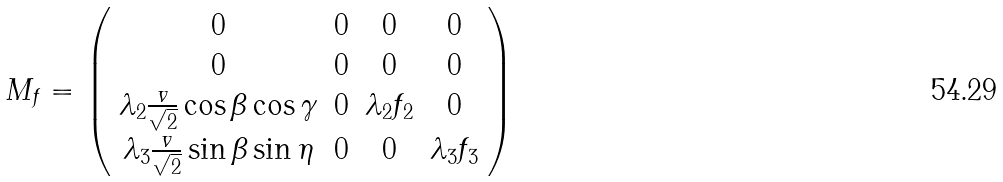<formula> <loc_0><loc_0><loc_500><loc_500>M _ { f } = \left ( \begin{array} { c c c c } 0 & 0 & 0 & 0 \\ 0 & 0 & 0 & 0 \\ \lambda _ { 2 } \frac { v } { \sqrt { 2 } } \cos \beta \cos \gamma & 0 & \lambda _ { 2 } f _ { 2 } & 0 \\ \lambda _ { 3 } \frac { v } { \sqrt { 2 } } \sin \beta \sin \eta & 0 & 0 & \lambda _ { 3 } f _ { 3 } \\ \end{array} \right )</formula> 